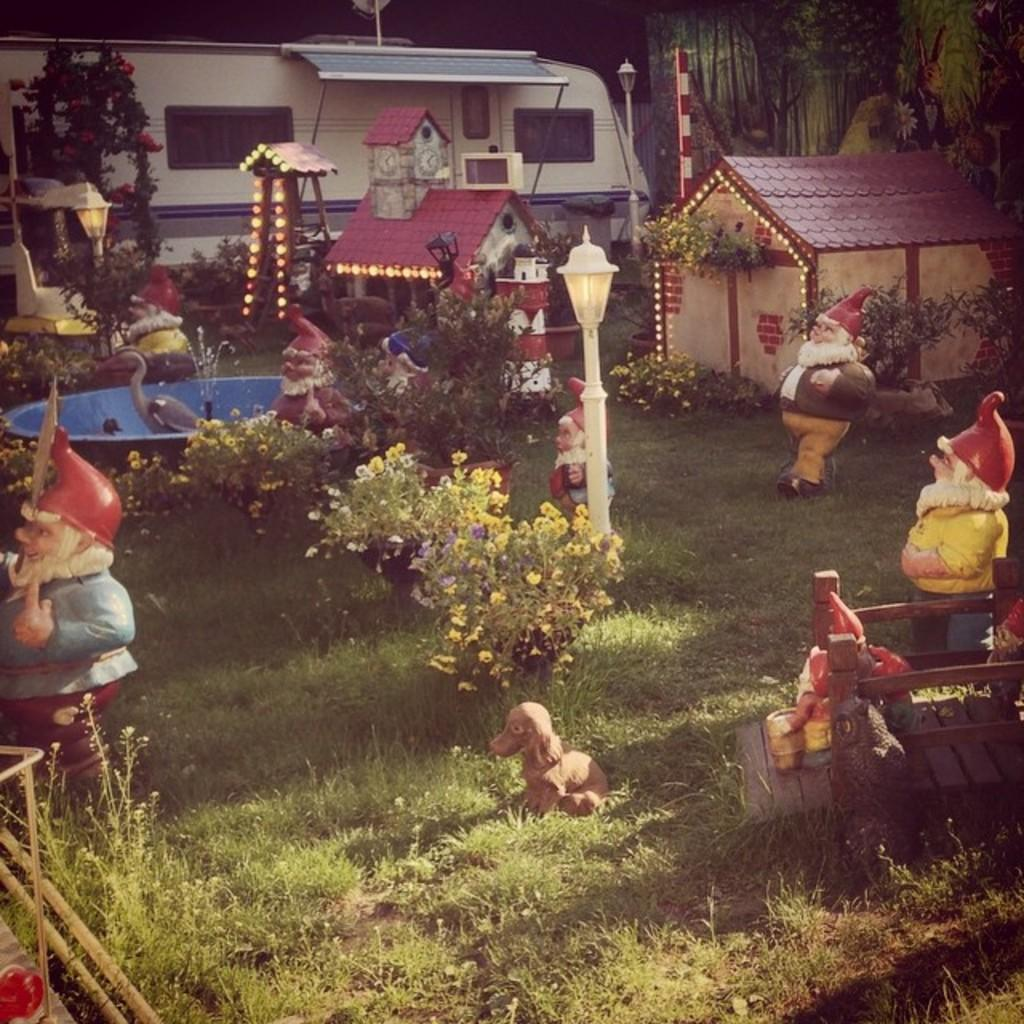What types of living organisms can be seen in the image? Plants and flower plants are visible in the image. What type of artwork can be seen in the image? There are sculptures in the image. What type of structures are present in the image? There are houses in the image. What mode of transportation is visible in the image? There is a vehicle in the image. What type of ground cover is visible in the image? Grass is visible in the image. What other objects can be seen on the ground in the image? There are other objects on the ground in the image. How many quinces are sitting on the chair in the image? There is no chair or quince present in the image. What type of door is visible in the image? There is no door visible in the image. 